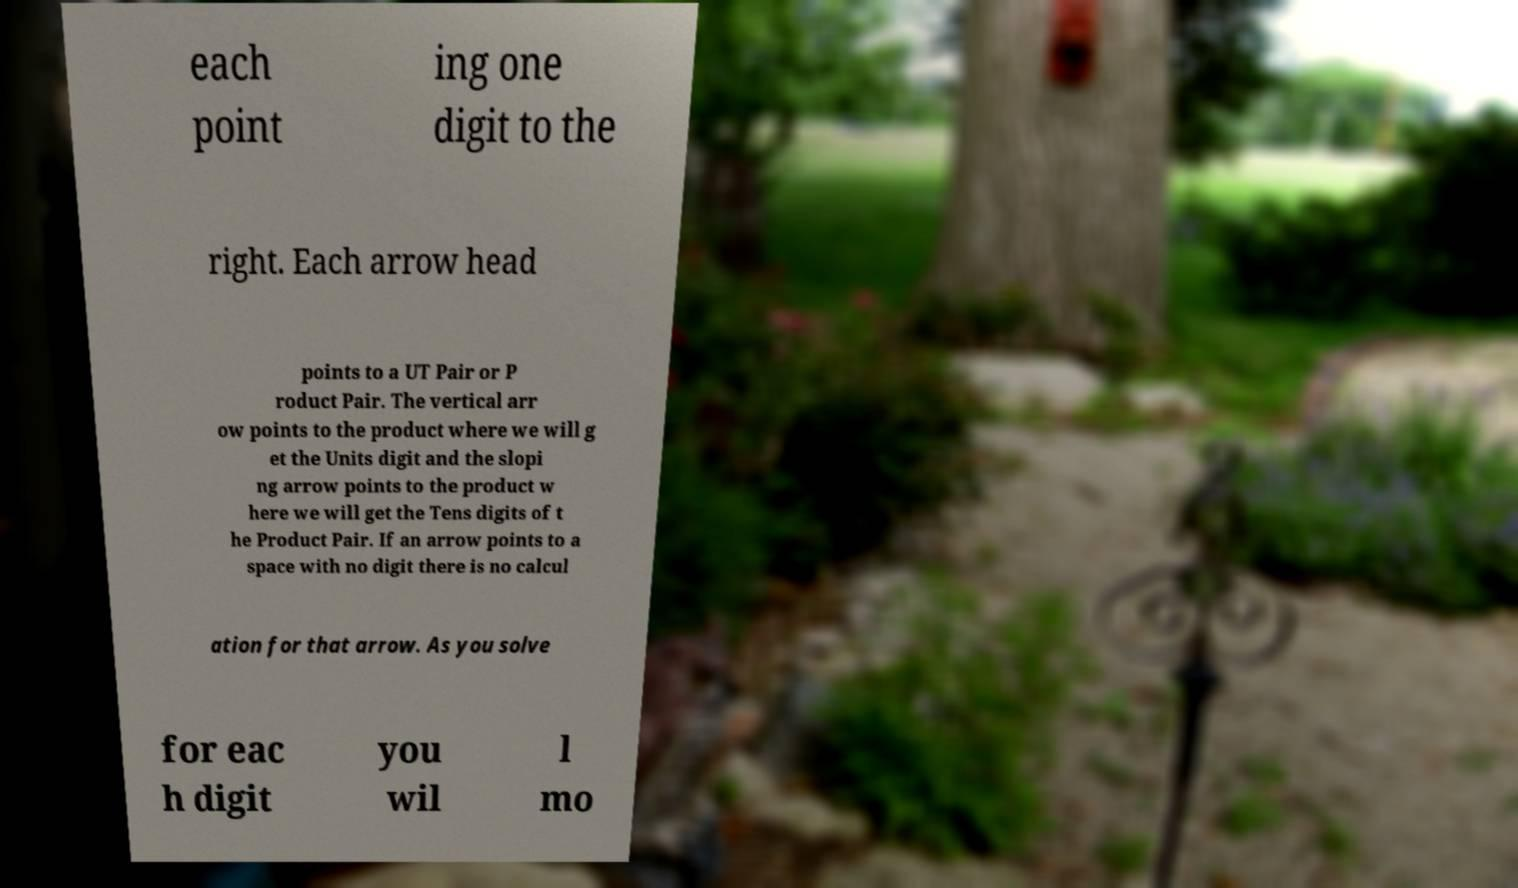There's text embedded in this image that I need extracted. Can you transcribe it verbatim? each point ing one digit to the right. Each arrow head points to a UT Pair or P roduct Pair. The vertical arr ow points to the product where we will g et the Units digit and the slopi ng arrow points to the product w here we will get the Tens digits of t he Product Pair. If an arrow points to a space with no digit there is no calcul ation for that arrow. As you solve for eac h digit you wil l mo 